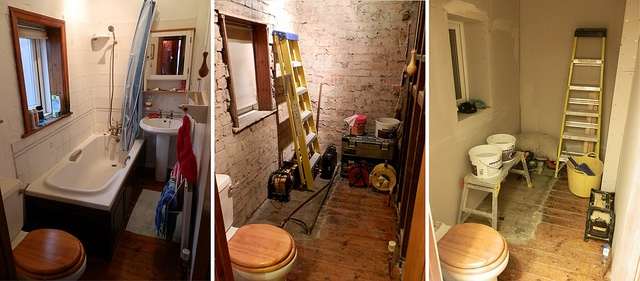Describe the objects in this image and their specific colors. I can see toilet in tan, maroon, black, and brown tones, toilet in tan, orange, salmon, brown, and maroon tones, toilet in tan, orange, red, and ivory tones, and sink in tan, gray, darkgray, black, and maroon tones in this image. 